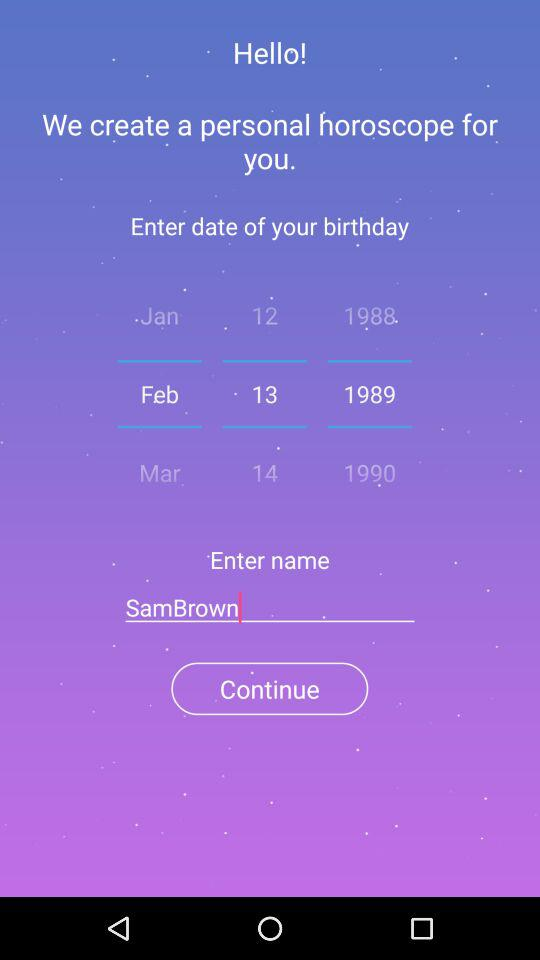What is the name of the person? The name of the person is SamBrown. 